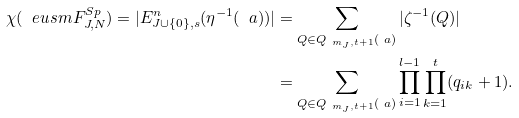Convert formula to latex. <formula><loc_0><loc_0><loc_500><loc_500>\chi ( \ e u s m F ^ { S p } _ { J , N } ) = | E ^ { n } _ { J \cup \{ 0 \} , s } ( \eta ^ { - 1 } ( \ a ) ) | & = \sum _ { Q \in Q _ { \ m _ { J } , t + 1 } ( \ a ) } | \zeta ^ { - 1 } ( Q ) | \\ & = \sum _ { Q \in Q _ { \ m _ { J } , t + 1 } ( \ a ) } \prod _ { i = 1 } ^ { l - 1 } \prod _ { k = 1 } ^ { t } ( q _ { i k } + 1 ) .</formula> 